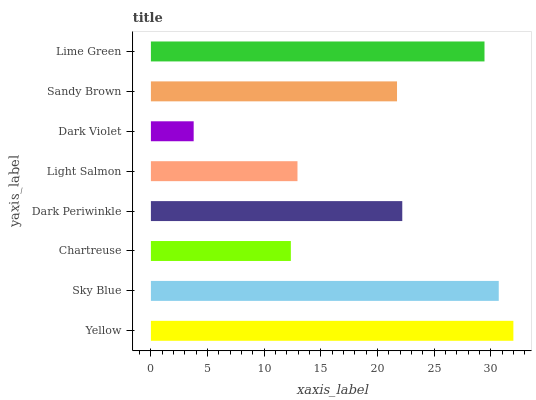Is Dark Violet the minimum?
Answer yes or no. Yes. Is Yellow the maximum?
Answer yes or no. Yes. Is Sky Blue the minimum?
Answer yes or no. No. Is Sky Blue the maximum?
Answer yes or no. No. Is Yellow greater than Sky Blue?
Answer yes or no. Yes. Is Sky Blue less than Yellow?
Answer yes or no. Yes. Is Sky Blue greater than Yellow?
Answer yes or no. No. Is Yellow less than Sky Blue?
Answer yes or no. No. Is Dark Periwinkle the high median?
Answer yes or no. Yes. Is Sandy Brown the low median?
Answer yes or no. Yes. Is Yellow the high median?
Answer yes or no. No. Is Chartreuse the low median?
Answer yes or no. No. 